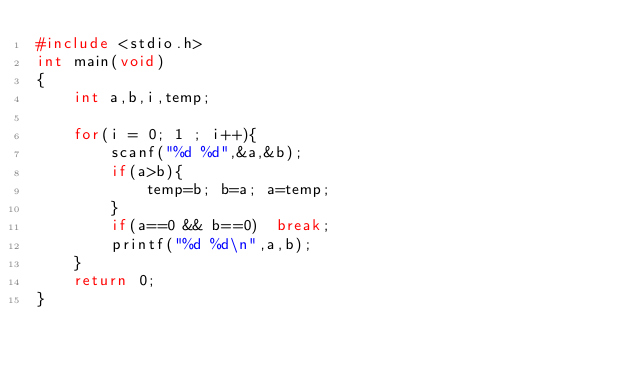Convert code to text. <code><loc_0><loc_0><loc_500><loc_500><_C_>#include <stdio.h>
int main(void)
{
	int a,b,i,temp;
	
	for(i = 0; 1 ; i++){
		scanf("%d %d",&a,&b);
		if(a>b){
			temp=b; b=a; a=temp;
		}
		if(a==0 && b==0)  break;
		printf("%d %d\n",a,b);
	}
	return 0;
}</code> 